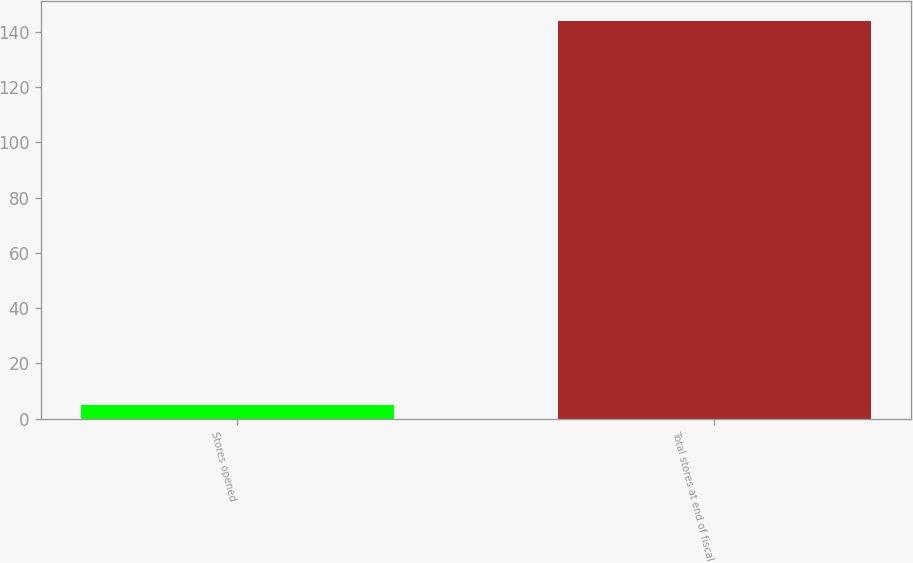<chart> <loc_0><loc_0><loc_500><loc_500><bar_chart><fcel>Stores opened<fcel>Total stores at end of fiscal<nl><fcel>5<fcel>144<nl></chart> 